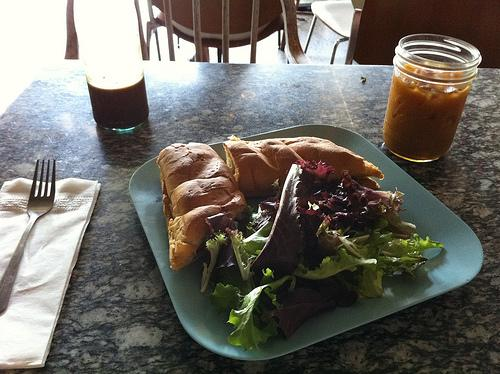Briefly describe the positioning of the fork and the napkin. The fork is placed on top of the white napkin which is on the grey table. Mention the two main food items served on the plate. A half of a bread sandwich and an assortment of leafy greens. Identify the object placed on the top left corner of the table. A clean silver fork placed on an unused white folded napkin. Choose a single detail found on the table and describe it. A small jar of salad dressing is placed on the table. What type of drink is in the glass jar and is it served with ice? The drink is a beverage served in a glass jar with ice in it. What kind of furniture can be seen around the table? There is a wooden chair with its backing visible next to the table, and a white chair across the table. Describe the color and shape of the plate on the table. The plate is a light blue square plate with round edges. What are the colors of the lettuce in the salad served on the plate? The lettuce in the salad is green and purple. Describe how the sandwich appears on the plate. There is a sandwich cut in half with light brown bread on the plate. What is the color of the table and describe any patterns or texture it might have. The table has a light grey granite top. 